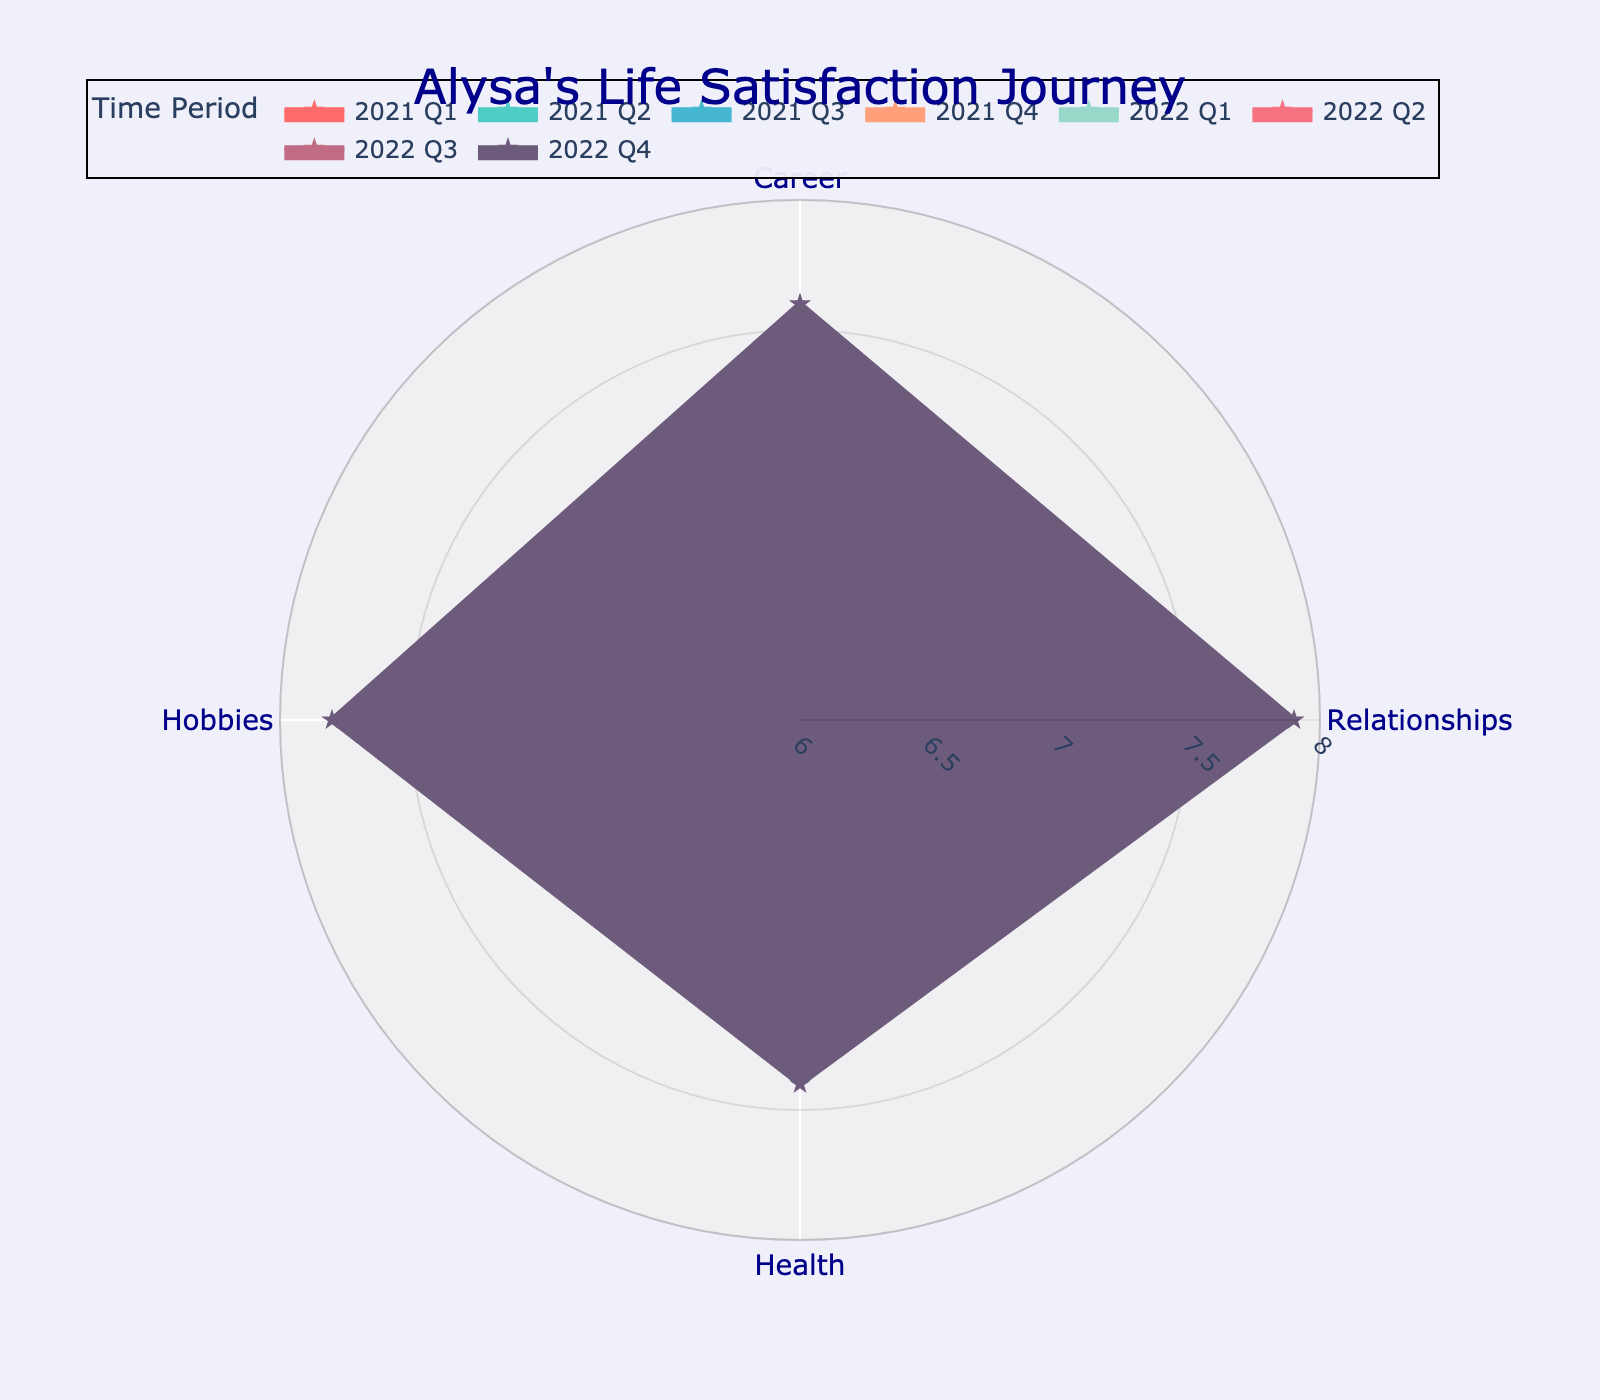What is the title of the figure? The title is found at the top of the figure. It reads "Alysa's Life Satisfaction Journey".
Answer: Alysa's Life Satisfaction Journey Which quarter had the highest overall life satisfaction in all categories? To determine this, review the lines on the radar chart to see which quarter has the largest area covered in all categories. That would be 2022 Q4.
Answer: 2022 Q4 How did Alysa's satisfaction in Career change from 2021 Q1 to 2022 Q4? Locate the line for Career and compare the points for 2021 Q1 and 2022 Q4. In 2021 Q1, Alysa's satisfaction was 6.8, and in 2022 Q4, it was 7.6. The change is 7.6 - 6.8 = 0.8.
Answer: Increased by 0.8 Which category saw the largest improvement from 2021 Q1 to 2022 Q4? Analyze the points for all categories between 2021 Q1 and 2022 Q4 and calculate the differences: Career (0.8), Relationships (0.7), Health (0.9), and Hobbies (0.8). The largest improvement is in Health.
Answer: Health What was Alysa's average satisfaction score across all categories in 2022 Q1? For 2022 Q1, add up Alysa's satisfaction scores across all categories and divide by the number of categories: (7.2 + 7.5 + 7.0 + 7.4) / 4 = 7.275.
Answer: 7.275 Did any category show a decrease in satisfaction across all eight quarters? Review each category's points across the eight quarters to see if any category has a consistently decreasing trend. None of the categories show a decrease across all quarters; they all have an increasing trend.
Answer: No Which quarter shows the highest satisfaction in Health? Look for the quarter with the highest point in the Health category. That would be 2022 Q4 with a score of 7.4.
Answer: 2022 Q4 Between which two consecutive quarters did Relationships satisfaction increase the most? Check the differences in the Relationships scores between consecutive quarters: Q1-Q2 (0.2), Q2-Q3 (0.1), Q3-Q4 (0.1), Q4-Q1 (0.0), Q1-Q2 (0.2), Q2-Q3 (0.1), Q3-Q4 (0.1). The largest increase is between 2022 Q1 and 2022 Q2.
Answer: Between 2022 Q1 and 2022 Q2 What was the minimum satisfaction score for Hobbies over all quarters? Find the lowest point in the Hobbies category across all quarters. The minimum satisfaction score is 7.0 in 2021 Q1.
Answer: 7.0 